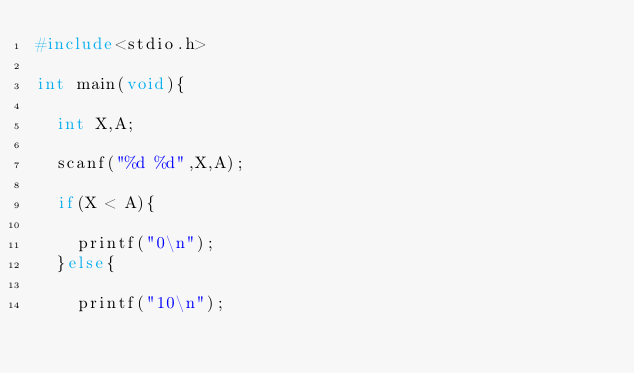<code> <loc_0><loc_0><loc_500><loc_500><_C_>#include<stdio.h>

int main(void){
  
  int X,A;
  
  scanf("%d %d",X,A);
 
  if(X < A){
    
    printf("0\n");
  }else{
    
    printf("10\n");</code> 